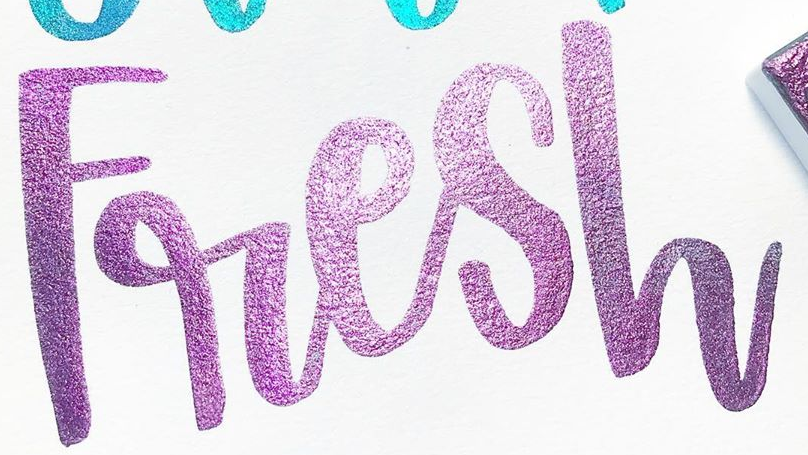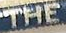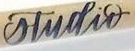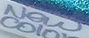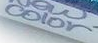Identify the words shown in these images in order, separated by a semicolon. Fresh; THE; studir; New; color 